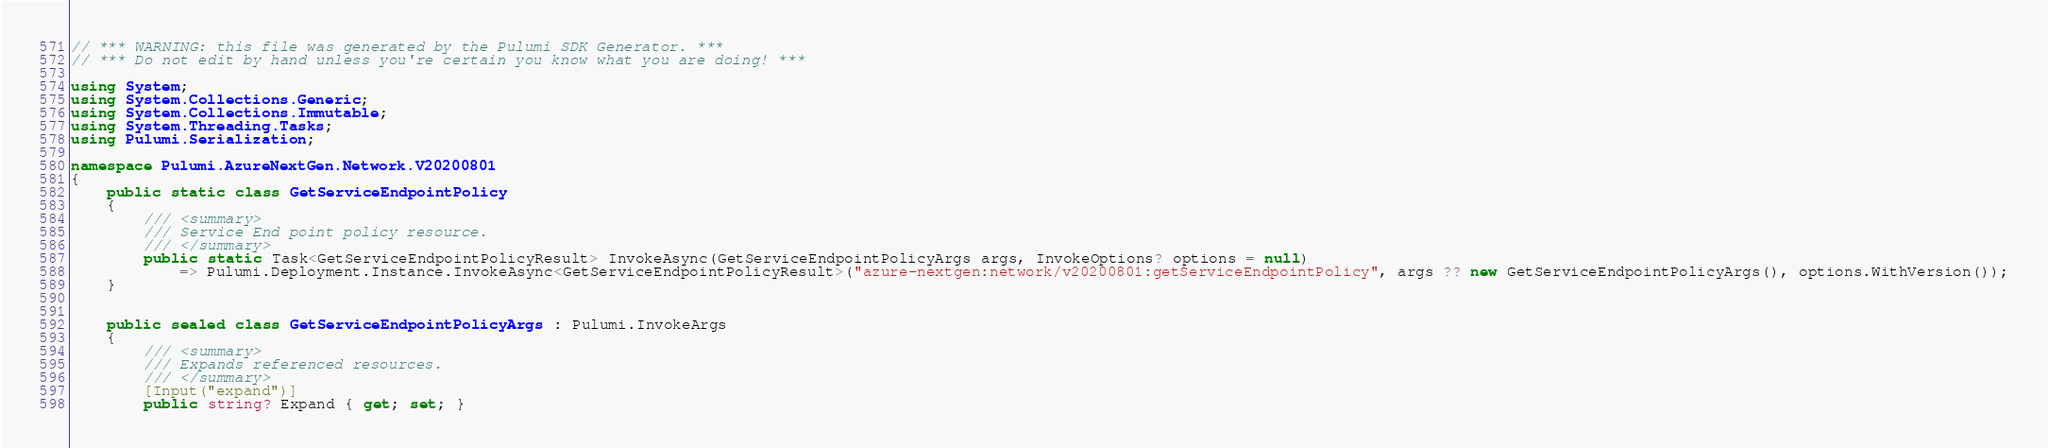Convert code to text. <code><loc_0><loc_0><loc_500><loc_500><_C#_>// *** WARNING: this file was generated by the Pulumi SDK Generator. ***
// *** Do not edit by hand unless you're certain you know what you are doing! ***

using System;
using System.Collections.Generic;
using System.Collections.Immutable;
using System.Threading.Tasks;
using Pulumi.Serialization;

namespace Pulumi.AzureNextGen.Network.V20200801
{
    public static class GetServiceEndpointPolicy
    {
        /// <summary>
        /// Service End point policy resource.
        /// </summary>
        public static Task<GetServiceEndpointPolicyResult> InvokeAsync(GetServiceEndpointPolicyArgs args, InvokeOptions? options = null)
            => Pulumi.Deployment.Instance.InvokeAsync<GetServiceEndpointPolicyResult>("azure-nextgen:network/v20200801:getServiceEndpointPolicy", args ?? new GetServiceEndpointPolicyArgs(), options.WithVersion());
    }


    public sealed class GetServiceEndpointPolicyArgs : Pulumi.InvokeArgs
    {
        /// <summary>
        /// Expands referenced resources.
        /// </summary>
        [Input("expand")]
        public string? Expand { get; set; }
</code> 